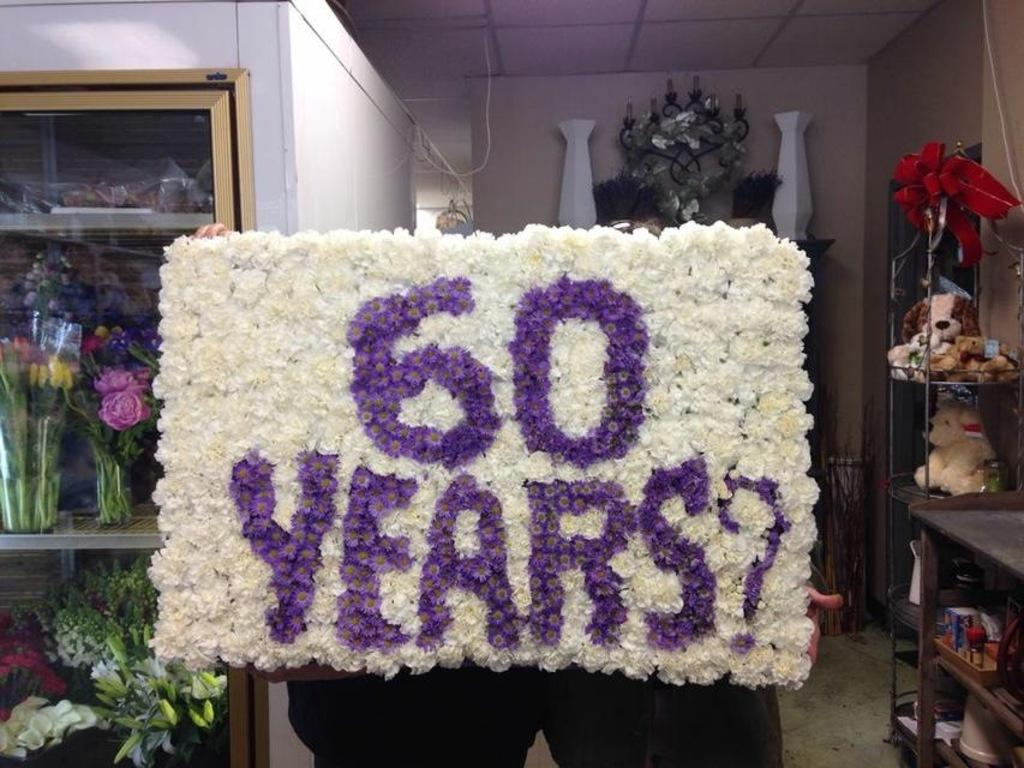<image>
Render a clear and concise summary of the photo. Persn holding a giant sign made of flowers that says 60 years. 